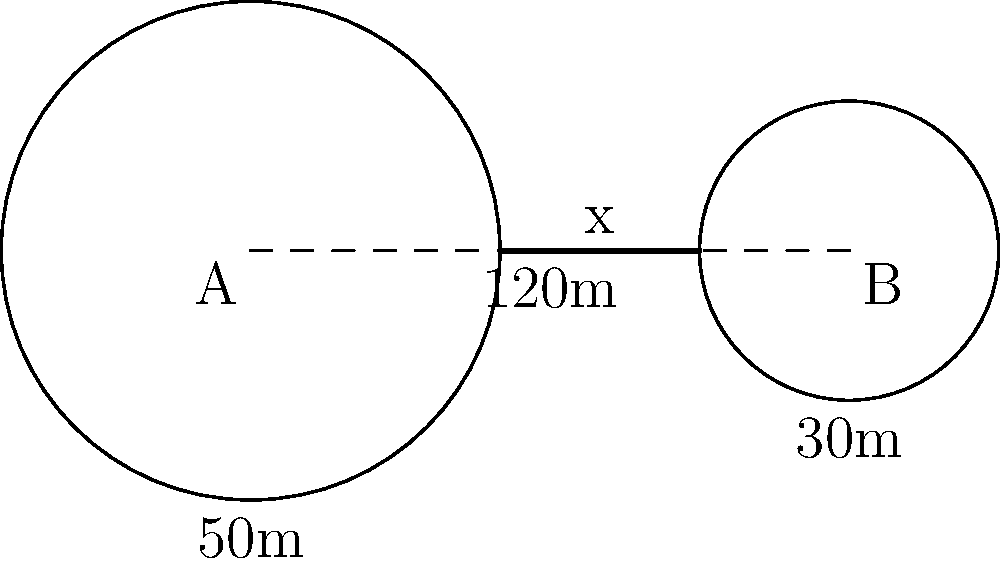Two circular water reservoirs are tangent to each other, as shown in the diagram. Reservoir A has a radius of 50m, and reservoir B has a radius of 30m. The centers of the reservoirs are 120m apart. Calculate the length of the straight pipe (x) needed to connect the two reservoirs at their tangent points. To solve this problem, we'll follow these steps:

1) First, we need to understand that the distance between the centers of the circles is equal to the sum of their radii. Let's call this distance $d$.

   $d = 120m = 50m + 30m + x$

2) We can rearrange this equation to solve for $x$:

   $x = d - (r_1 + r_2)$
   
   Where $r_1$ is the radius of reservoir A and $r_2$ is the radius of reservoir B.

3) Now we can substitute the known values:

   $x = 120m - (50m + 30m)$

4) Simplify:

   $x = 120m - 80m = 40m$

Therefore, the length of the pipe needed to connect the two reservoirs at their tangent points is 40m.
Answer: 40m 